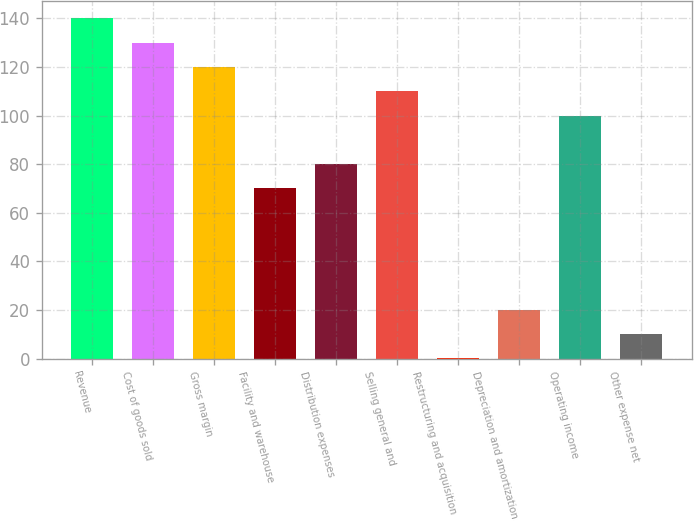Convert chart. <chart><loc_0><loc_0><loc_500><loc_500><bar_chart><fcel>Revenue<fcel>Cost of goods sold<fcel>Gross margin<fcel>Facility and warehouse<fcel>Distribution expenses<fcel>Selling general and<fcel>Restructuring and acquisition<fcel>Depreciation and amortization<fcel>Operating income<fcel>Other expense net<nl><fcel>139.96<fcel>129.97<fcel>119.98<fcel>70.03<fcel>80.02<fcel>109.99<fcel>0.1<fcel>20.08<fcel>100<fcel>10.09<nl></chart> 